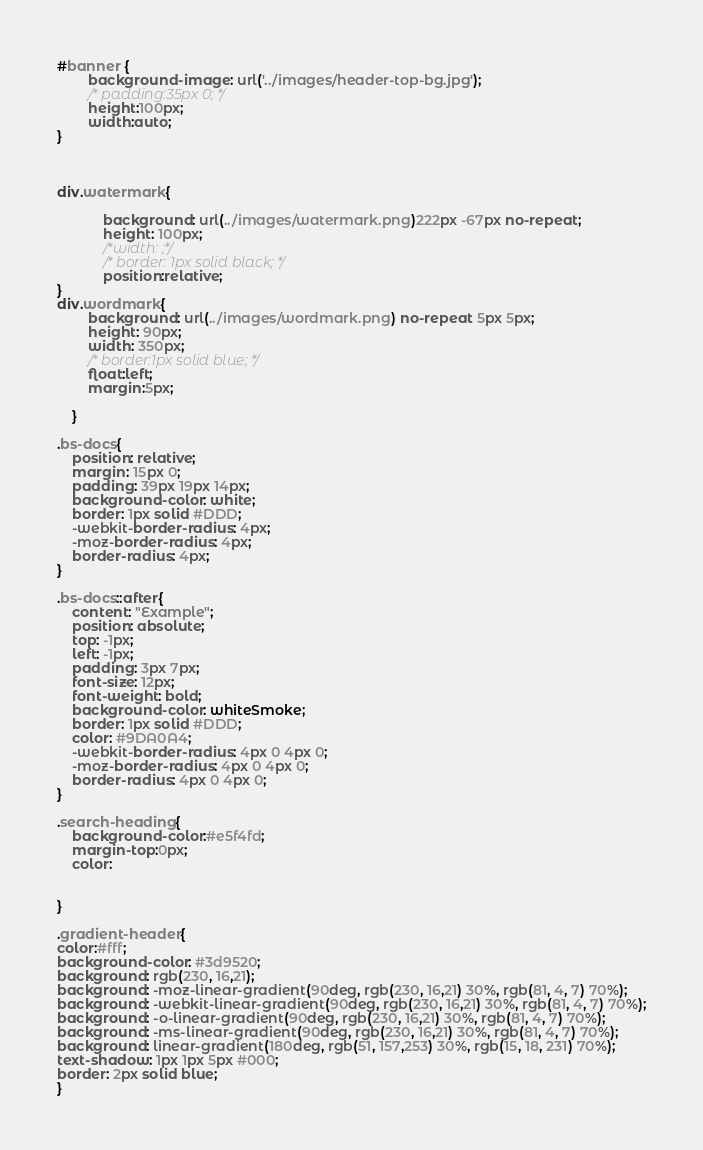<code> <loc_0><loc_0><loc_500><loc_500><_CSS_>#banner {
		background-image: url('../images/header-top-bg.jpg');
		/* padding:35px 0; */
		height:100px;
		width:auto;
}



div.watermark{

		    background: url(../images/watermark.png)222px -67px no-repeat;
			height: 100px;
			/*width: ;*/
			/* border: 1px solid black; */
			position:relative;
}
div.wordmark{
		background: url(../images/wordmark.png) no-repeat 5px 5px;
		height: 90px;
		width: 350px;
		/* border:1px solid blue; */
		float:left;
		margin:5px;
		
	}

.bs-docs{
    position: relative;
    margin: 15px 0;
    padding: 39px 19px 14px;
    background-color: white;
    border: 1px solid #DDD;
    -webkit-border-radius: 4px;
    -moz-border-radius: 4px;
    border-radius: 4px;
}

.bs-docs::after{
    content: "Example";
    position: absolute;
    top: -1px;
    left: -1px;
    padding: 3px 7px;
    font-size: 12px;
    font-weight: bold;
    background-color: whiteSmoke;
    border: 1px solid #DDD;
    color: #9DA0A4;
    -webkit-border-radius: 4px 0 4px 0;
    -moz-border-radius: 4px 0 4px 0;
    border-radius: 4px 0 4px 0;
}

.search-heading{
	background-color:#e5f4fd;
	margin-top:0px;
	color: 
	
	
}

.gradient-header{
color:#fff;
background-color: #3d9520;
background: rgb(230, 16,21);
background: -moz-linear-gradient(90deg, rgb(230, 16,21) 30%, rgb(81, 4, 7) 70%);
background: -webkit-linear-gradient(90deg, rgb(230, 16,21) 30%, rgb(81, 4, 7) 70%);
background: -o-linear-gradient(90deg, rgb(230, 16,21) 30%, rgb(81, 4, 7) 70%);
background: -ms-linear-gradient(90deg, rgb(230, 16,21) 30%, rgb(81, 4, 7) 70%);
background: linear-gradient(180deg, rgb(51, 157,253) 30%, rgb(15, 18, 231) 70%);
text-shadow: 1px 1px 5px #000;
border: 2px solid blue;
}

</code> 